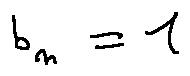Convert formula to latex. <formula><loc_0><loc_0><loc_500><loc_500>b _ { n } = 1</formula> 